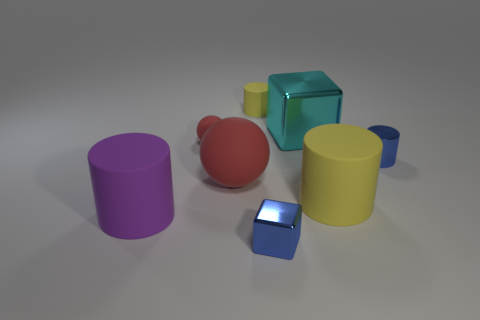Is the big shiny thing the same shape as the big red object?
Ensure brevity in your answer.  No. How many yellow objects are big matte objects or rubber spheres?
Your answer should be very brief. 1. There is another red object that is made of the same material as the small red object; what is its size?
Ensure brevity in your answer.  Large. Does the tiny yellow thing that is behind the large purple cylinder have the same material as the small cube in front of the tiny blue cylinder?
Keep it short and to the point. No. How many cubes are either big red matte objects or tiny red objects?
Offer a very short reply. 0. There is a tiny rubber object that is in front of the yellow cylinder that is behind the large red sphere; what number of small blue cylinders are on the right side of it?
Provide a short and direct response. 1. What is the material of the other object that is the same shape as the large cyan thing?
Ensure brevity in your answer.  Metal. What is the color of the tiny metallic object in front of the large purple cylinder?
Your answer should be compact. Blue. Is the tiny ball made of the same material as the yellow thing that is in front of the cyan shiny thing?
Your response must be concise. Yes. What material is the small yellow object?
Ensure brevity in your answer.  Rubber. 